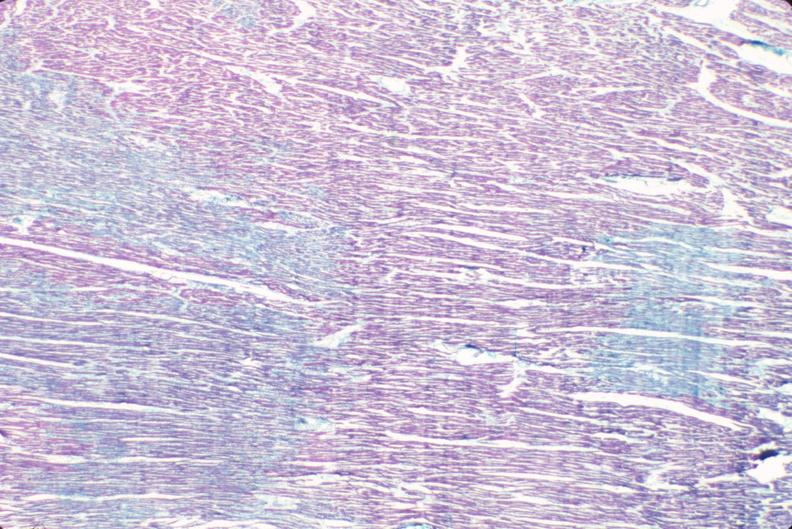does peritoneal fluid show heart, acute myocardial infarction?
Answer the question using a single word or phrase. No 